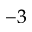<formula> <loc_0><loc_0><loc_500><loc_500>^ { - 3 }</formula> 